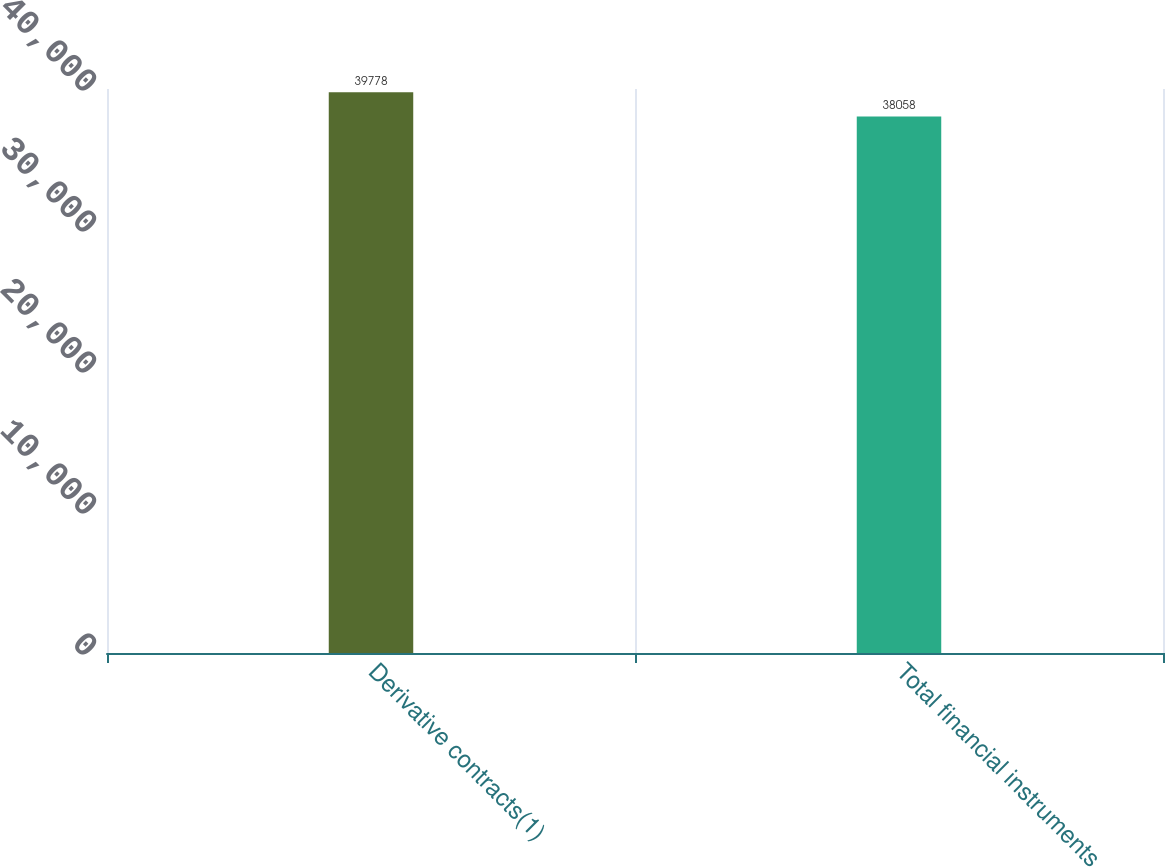Convert chart to OTSL. <chart><loc_0><loc_0><loc_500><loc_500><bar_chart><fcel>Derivative contracts(1)<fcel>Total financial instruments<nl><fcel>39778<fcel>38058<nl></chart> 